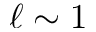Convert formula to latex. <formula><loc_0><loc_0><loc_500><loc_500>\ell \sim 1</formula> 